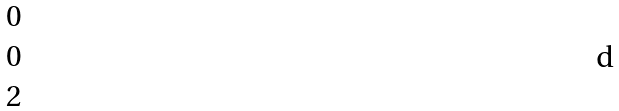<formula> <loc_0><loc_0><loc_500><loc_500>\begin{matrix} 0 \\ 0 \\ 2 \end{matrix}</formula> 